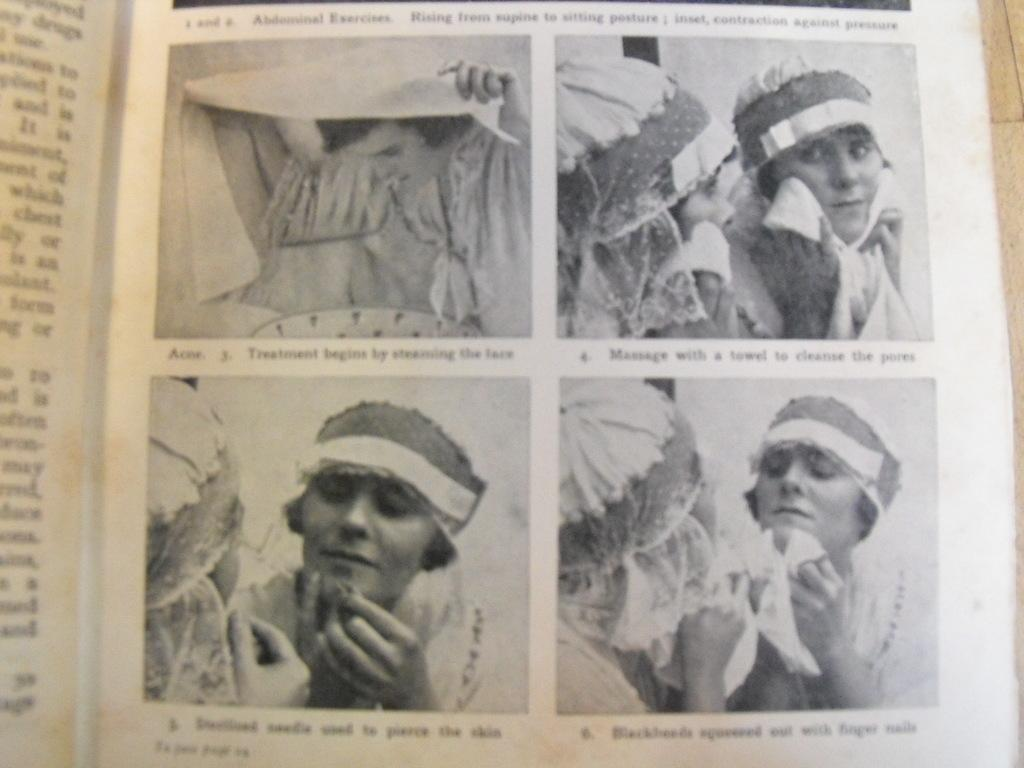What is present in the image that contains both text and images? There is a poster in the image that contains text and images. Can you describe the content of the poster? The poster contains text and images, but the specific content cannot be determined from the provided facts. How many jellyfish are swimming in the poster? There is no mention of jellyfish in the image or the provided facts, so it cannot be determined if any are present. 